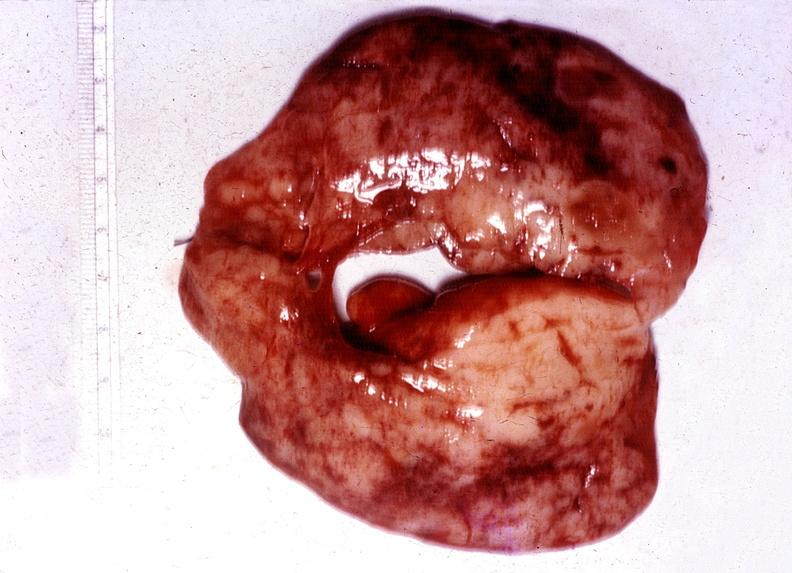s endocrine present?
Answer the question using a single word or phrase. Yes 